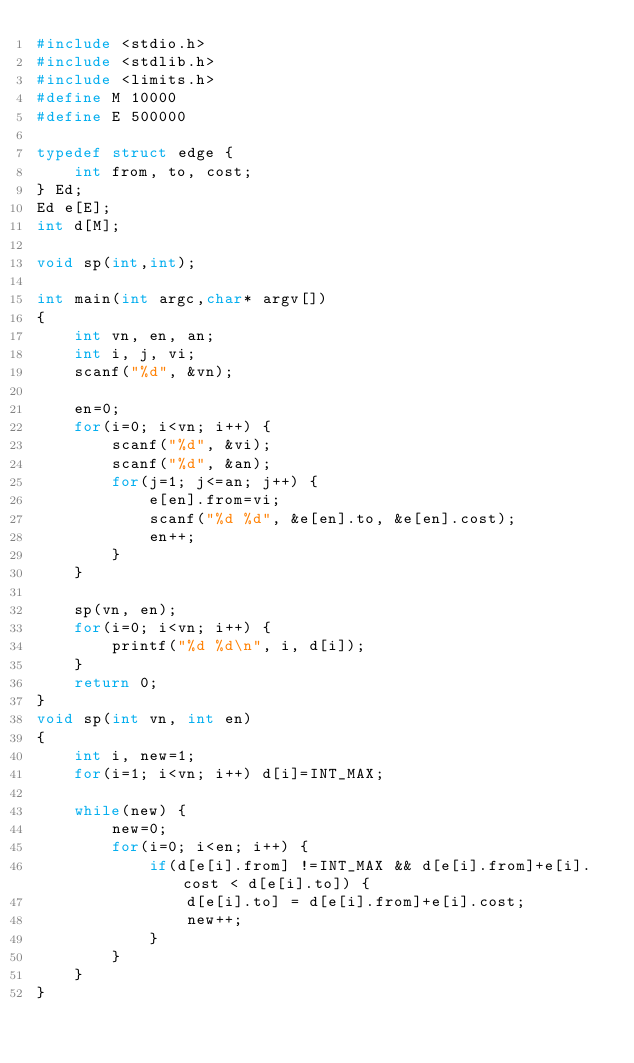<code> <loc_0><loc_0><loc_500><loc_500><_C_>#include <stdio.h>
#include <stdlib.h>
#include <limits.h>
#define M 10000
#define E 500000
   
typedef struct edge {
    int from, to, cost;
} Ed;
Ed e[E];
int d[M];
   
void sp(int,int);
  
int main(int argc,char* argv[])
{
    int vn, en, an;
    int i, j, vi;
    scanf("%d", &vn);
   
    en=0;
    for(i=0; i<vn; i++) {
        scanf("%d", &vi);
        scanf("%d", &an);
        for(j=1; j<=an; j++) {
            e[en].from=vi;
            scanf("%d %d", &e[en].to, &e[en].cost);
            en++;
        }
    }
       
    sp(vn, en);
    for(i=0; i<vn; i++) {
        printf("%d %d\n", i, d[i]);
    }
    return 0;
}
void sp(int vn, int en)
{
    int i, new=1;
    for(i=1; i<vn; i++) d[i]=INT_MAX;
       
    while(new) {
        new=0;
        for(i=0; i<en; i++) {
            if(d[e[i].from] !=INT_MAX && d[e[i].from]+e[i].cost < d[e[i].to]) {
                d[e[i].to] = d[e[i].from]+e[i].cost;
                new++;
            }
        }
    }
}</code> 